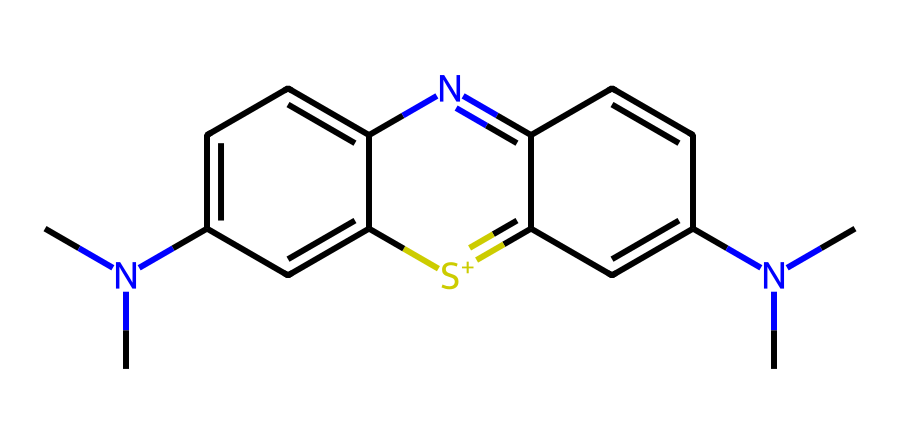What is the name of this chemical? The SMILES representation indicates the structure corresponds to methylene blue, which is a well-known photoreactive dye.
Answer: methylene blue How many nitrogen atoms are present in the structure? By analyzing the SMILES, we identify three nitrogen atoms within the cyclic structures and as part of the amine groups.
Answer: three How many rings are present in the chemical structure? The chemical structure contains two fused ring systems, which can be visualized in the SMILES representation.
Answer: two What type of bonding is primarily present in methylene blue? The structure indicates the presence of both single and double bonds, typical for organic structures, with resonance contributing to stability.
Answer: conjugated bonds What functional groups are identified in methylene blue? The chemical contains amine groups (due to the nitrogen atoms) and a sulfonium ion, shown by the positively charged sulfur atom.
Answer: amine and sulfonium What property of methylene blue allows it to be photoreactive? The presence of a conjugated system of alternating double bonds allows for electron excitation when exposed to light, making it photoreactive.
Answer: conjugated system In which diagnostic procedures is methylene blue commonly used? Methylene blue is frequently employed in procedures like methylene blue dye tests during surgeries or in identifying sentinel lymph nodes.
Answer: sentinel lymph node biopsy 